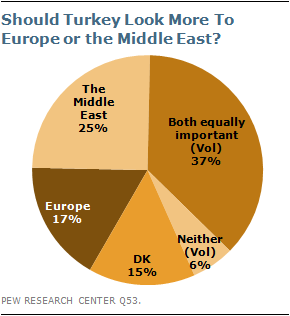Specify some key components in this picture. The largest and smallest values of the Pie chart represent a significant difference. The value of the largest pie in the chart is 37. 